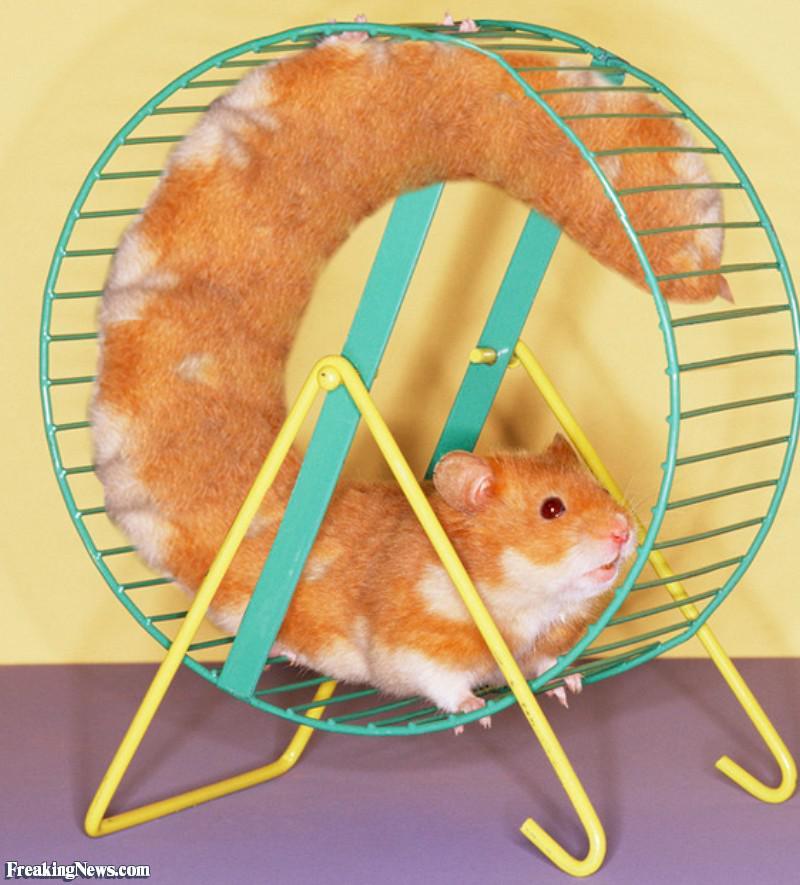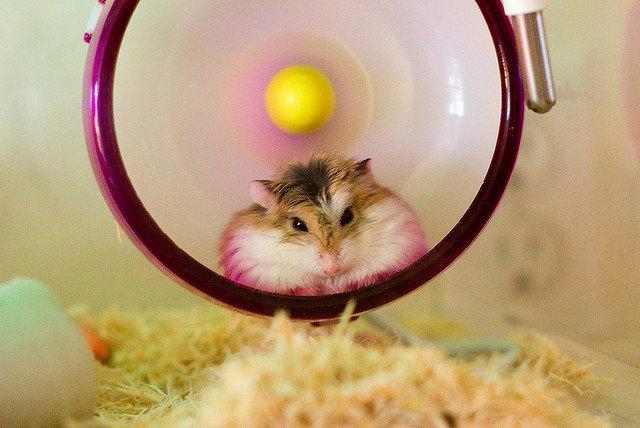The first image is the image on the left, the second image is the image on the right. Examine the images to the left and right. Is the description "One image includes a wheel and at least one hamster, but the hamster is not in a running position." accurate? Answer yes or no. Yes. The first image is the image on the left, the second image is the image on the right. Evaluate the accuracy of this statement regarding the images: "One of the hamsters is in a metal wheel.". Is it true? Answer yes or no. Yes. 